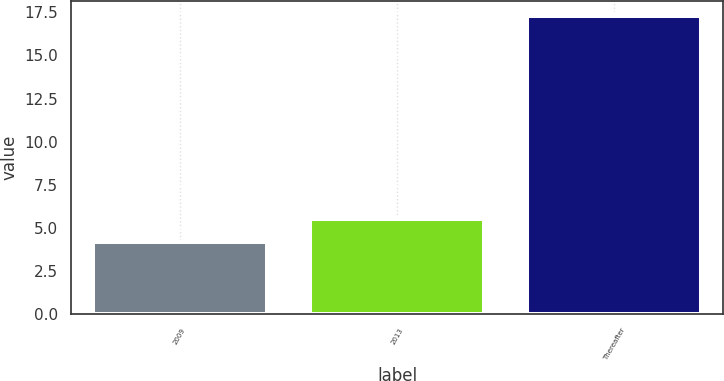Convert chart. <chart><loc_0><loc_0><loc_500><loc_500><bar_chart><fcel>2009<fcel>2013<fcel>Thereafter<nl><fcel>4.2<fcel>5.51<fcel>17.3<nl></chart> 